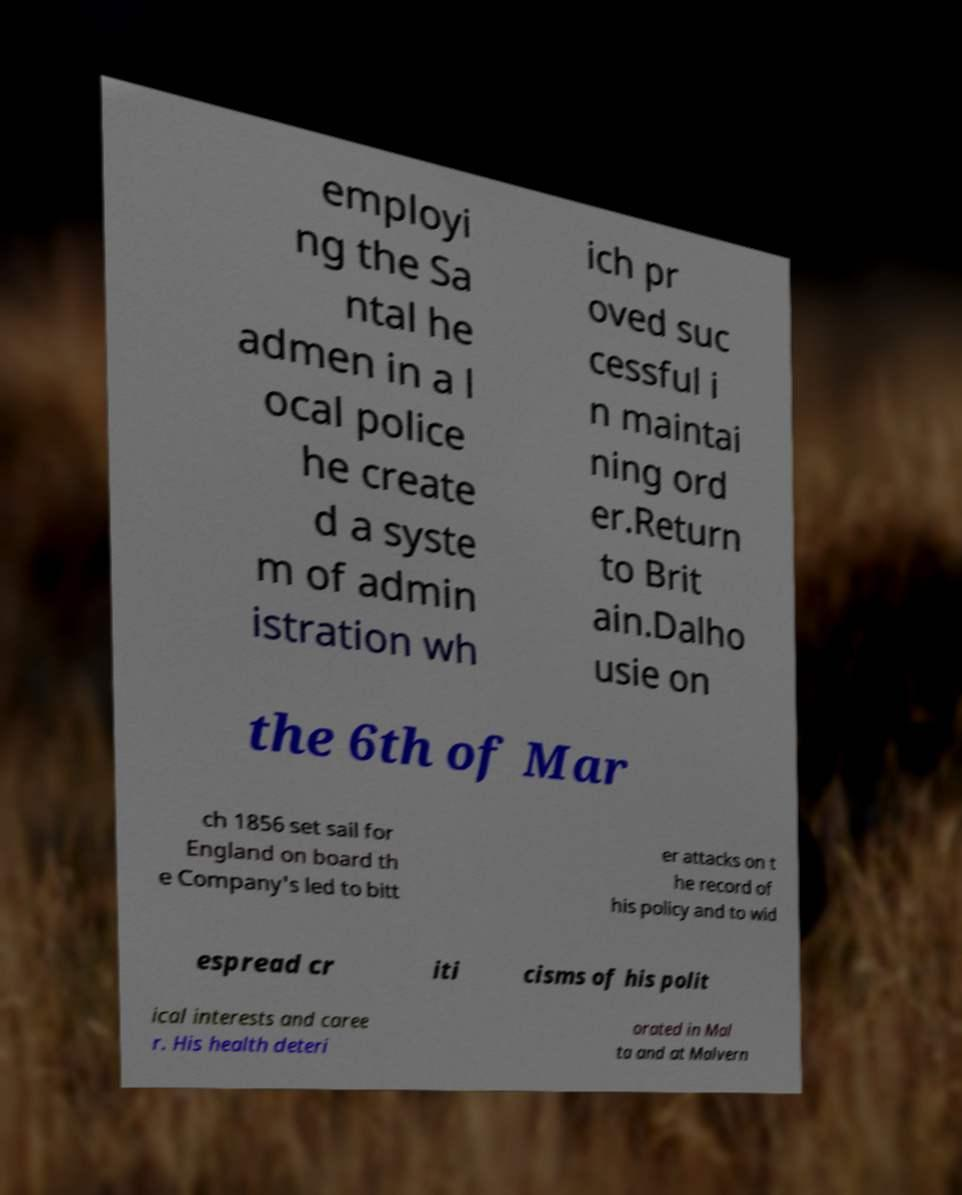Could you extract and type out the text from this image? employi ng the Sa ntal he admen in a l ocal police he create d a syste m of admin istration wh ich pr oved suc cessful i n maintai ning ord er.Return to Brit ain.Dalho usie on the 6th of Mar ch 1856 set sail for England on board th e Company's led to bitt er attacks on t he record of his policy and to wid espread cr iti cisms of his polit ical interests and caree r. His health deteri orated in Mal ta and at Malvern 